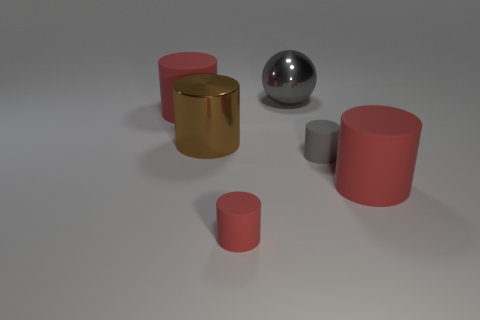There is a object that is the same color as the ball; what size is it?
Keep it short and to the point. Small. What is the red cylinder that is behind the metal cylinder made of?
Your response must be concise. Rubber. What number of big objects are gray matte objects or red cylinders?
Offer a terse response. 2. Does the rubber cylinder behind the gray rubber object have the same size as the gray matte object?
Your answer should be compact. No. What number of other things are there of the same color as the sphere?
Keep it short and to the point. 1. What is the material of the large gray thing?
Keep it short and to the point. Metal. The thing that is both on the right side of the gray shiny ball and in front of the tiny gray cylinder is made of what material?
Your response must be concise. Rubber. What number of things are either big red cylinders in front of the metal cylinder or metal cylinders?
Keep it short and to the point. 2. Is the shiny ball the same color as the large metallic cylinder?
Your answer should be compact. No. Are there any gray matte cylinders of the same size as the brown cylinder?
Give a very brief answer. No. 